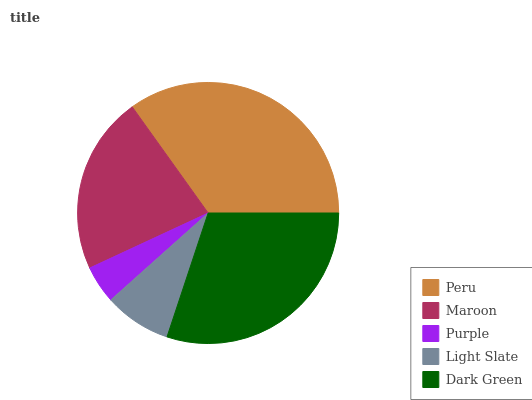Is Purple the minimum?
Answer yes or no. Yes. Is Peru the maximum?
Answer yes or no. Yes. Is Maroon the minimum?
Answer yes or no. No. Is Maroon the maximum?
Answer yes or no. No. Is Peru greater than Maroon?
Answer yes or no. Yes. Is Maroon less than Peru?
Answer yes or no. Yes. Is Maroon greater than Peru?
Answer yes or no. No. Is Peru less than Maroon?
Answer yes or no. No. Is Maroon the high median?
Answer yes or no. Yes. Is Maroon the low median?
Answer yes or no. Yes. Is Dark Green the high median?
Answer yes or no. No. Is Light Slate the low median?
Answer yes or no. No. 